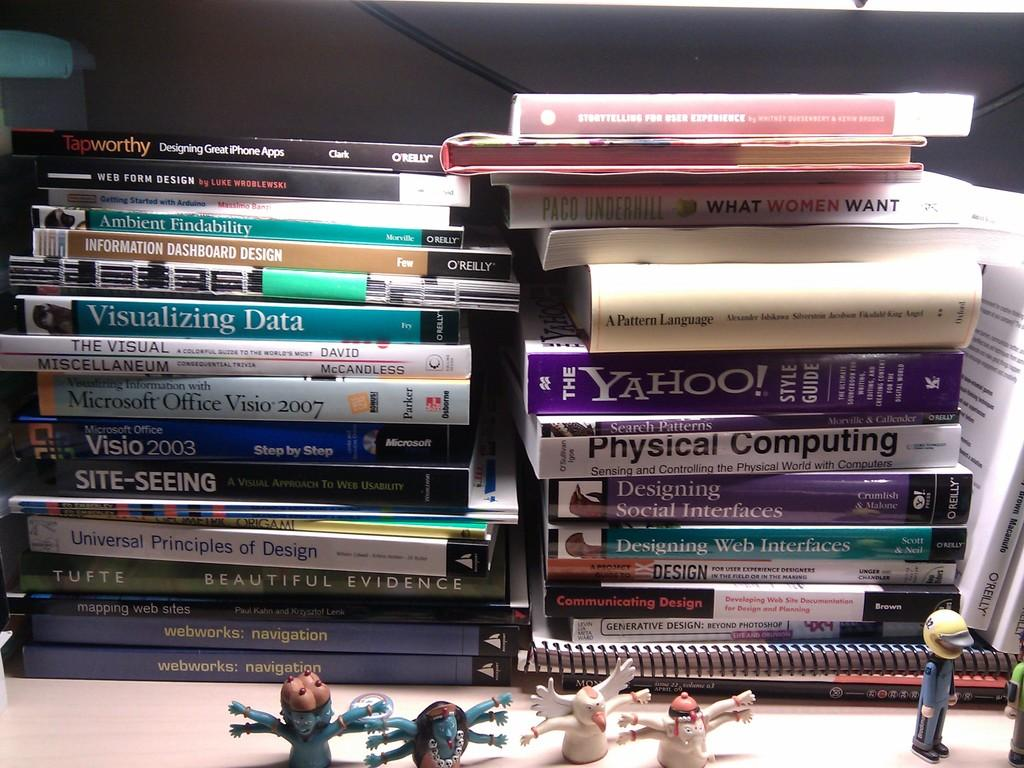<image>
Offer a succinct explanation of the picture presented. A large collection of computer and web design books lay on a desk. 